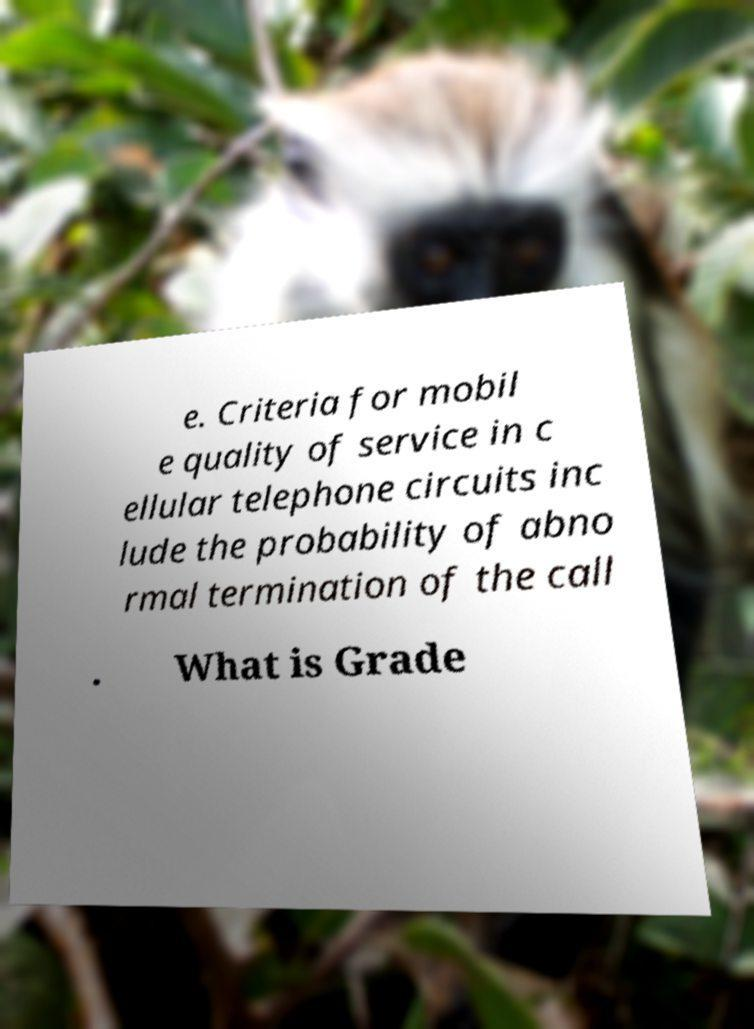Can you read and provide the text displayed in the image?This photo seems to have some interesting text. Can you extract and type it out for me? e. Criteria for mobil e quality of service in c ellular telephone circuits inc lude the probability of abno rmal termination of the call . What is Grade 